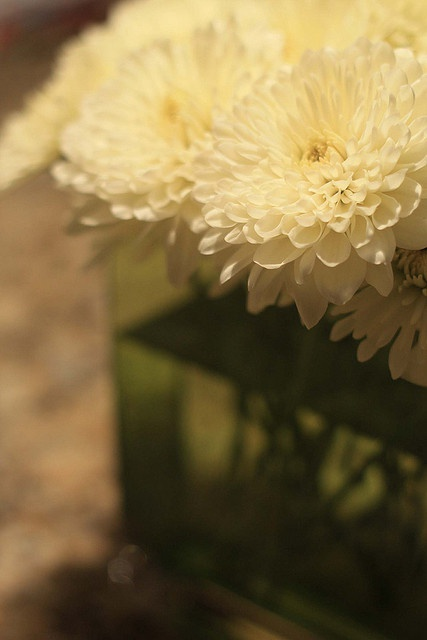Describe the objects in this image and their specific colors. I can see a vase in gray, black, and olive tones in this image. 